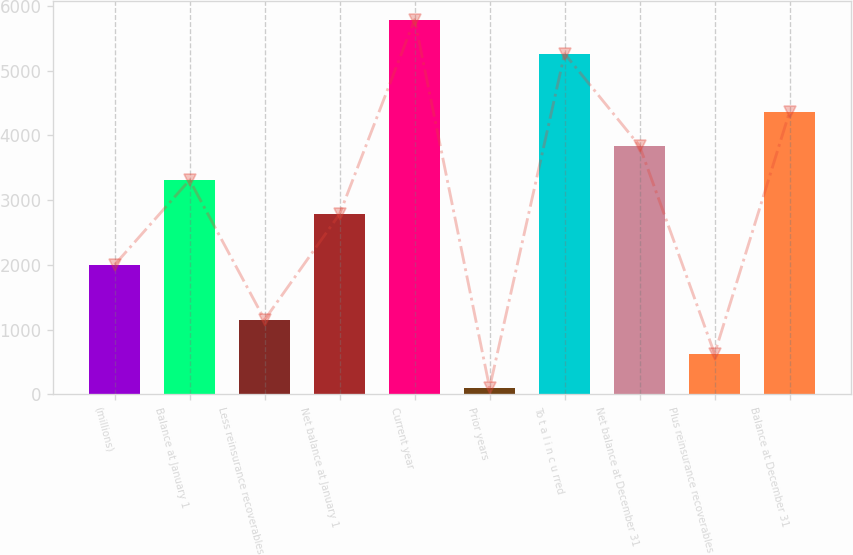Convert chart to OTSL. <chart><loc_0><loc_0><loc_500><loc_500><bar_chart><fcel>(millions)<fcel>Balance at January 1<fcel>Less reinsurance recoverables<fcel>Net balance at January 1<fcel>Current year<fcel>Prior years<fcel>To t a l i n c u rred<fcel>Net balance at December 31<fcel>Plus reinsurance recoverables<fcel>Balance at December 31<nl><fcel>2001<fcel>3311.71<fcel>1151.82<fcel>2785.3<fcel>5790.51<fcel>99<fcel>5264.1<fcel>3838.12<fcel>625.41<fcel>4364.53<nl></chart> 